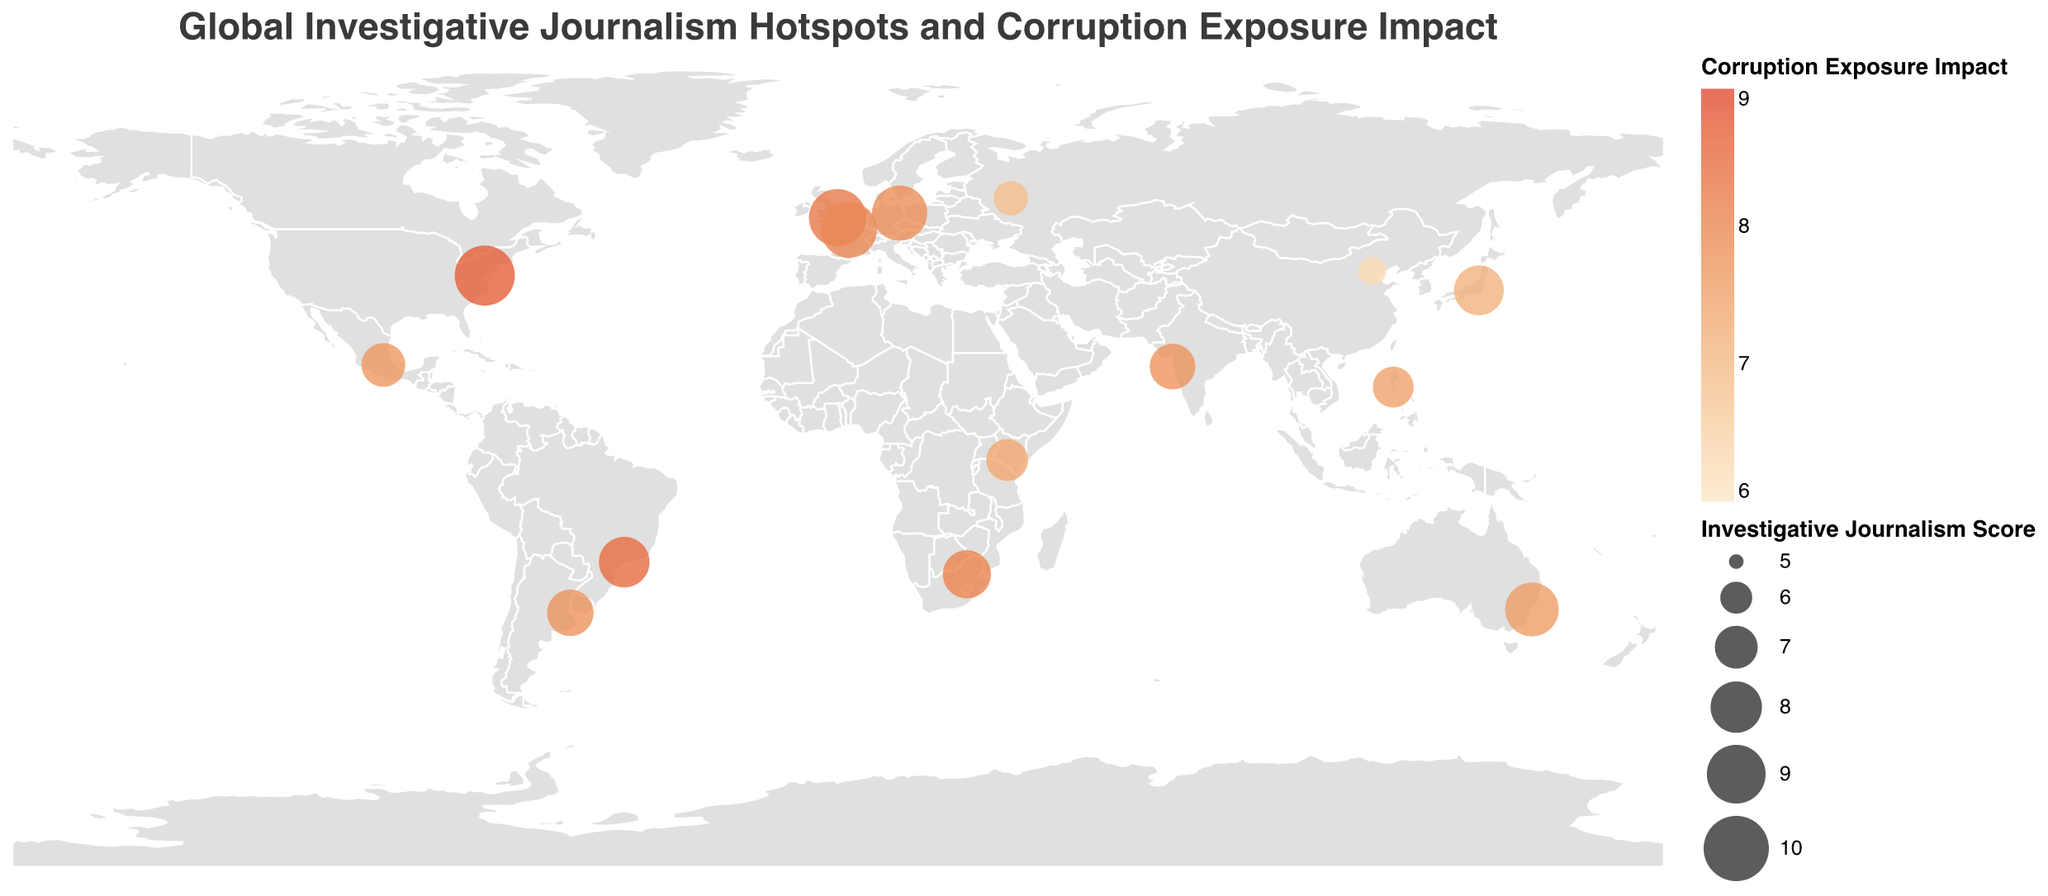What's the title of the figure? The title of the figure is clearly displayed at the top.
Answer: Global Investigative Journalism Hotspots and Corruption Exposure Impact How many cities are displayed in the figure? By counting the number of data points (circles) on the map, you can determine the number of cities.
Answer: 14 Which city has the highest Investigative Journalism Score? Look for the largest circle on the map, which corresponds to the city with the highest Investigative Journalism Score.
Answer: Washington D.C What is the Corruption Exposure Impact of Berlin? Hover over the circle representing Berlin to see the tooltip displaying the Corruption Exposure Impact.
Answer: 7.9 How does the Investigative Journalism Score of São Paulo compare to that of Sydney? Find both São Paulo and Sydney on the map and compare the sizes of their circles; São Paulo's circle is slightly smaller than Sydney's.
Answer: São Paulo's score is lower Which city in Europe has the highest Corruption Exposure Impact? Identify European cities on the map and compare their circle colors, the darkest red indicates the highest impact.
Answer: London What is the average Investigative Journalism Score of the cities displayed? Sum all the Investigative Journalism Scores and divide by the number of cities: (9.2 + 8.8 + 8.5 + 7.9 + 7.6 + 7.3 + 6.8 + 6.2 + 5.7 + 7.1 + 8.3 + 8.6 + 6.9 + 7.4 + 7.8) / 14 = 7.578.
Answer: 7.6 Which continent has the most cities represented in the figure? Count the number of cities in each continent by identifying their geographic locations on the map. Europe has 4 cities (London, Berlin, Paris, Moscow).
Answer: Europe Is there a correlation between Investigative Journalism Score and Corruption Exposure Impact? Observe the scatter of circle sizes (Investigative Journalism Score) and their color intensity (Corruption Exposure Impact) across the map to infer correlation.
Answer: Positive correlation Which city has the lowest Corruption Exposure Impact? Look for the circle with the lightest color on the map, hover over it to confirm the Corruption Exposure Impact.
Answer: Beijing 